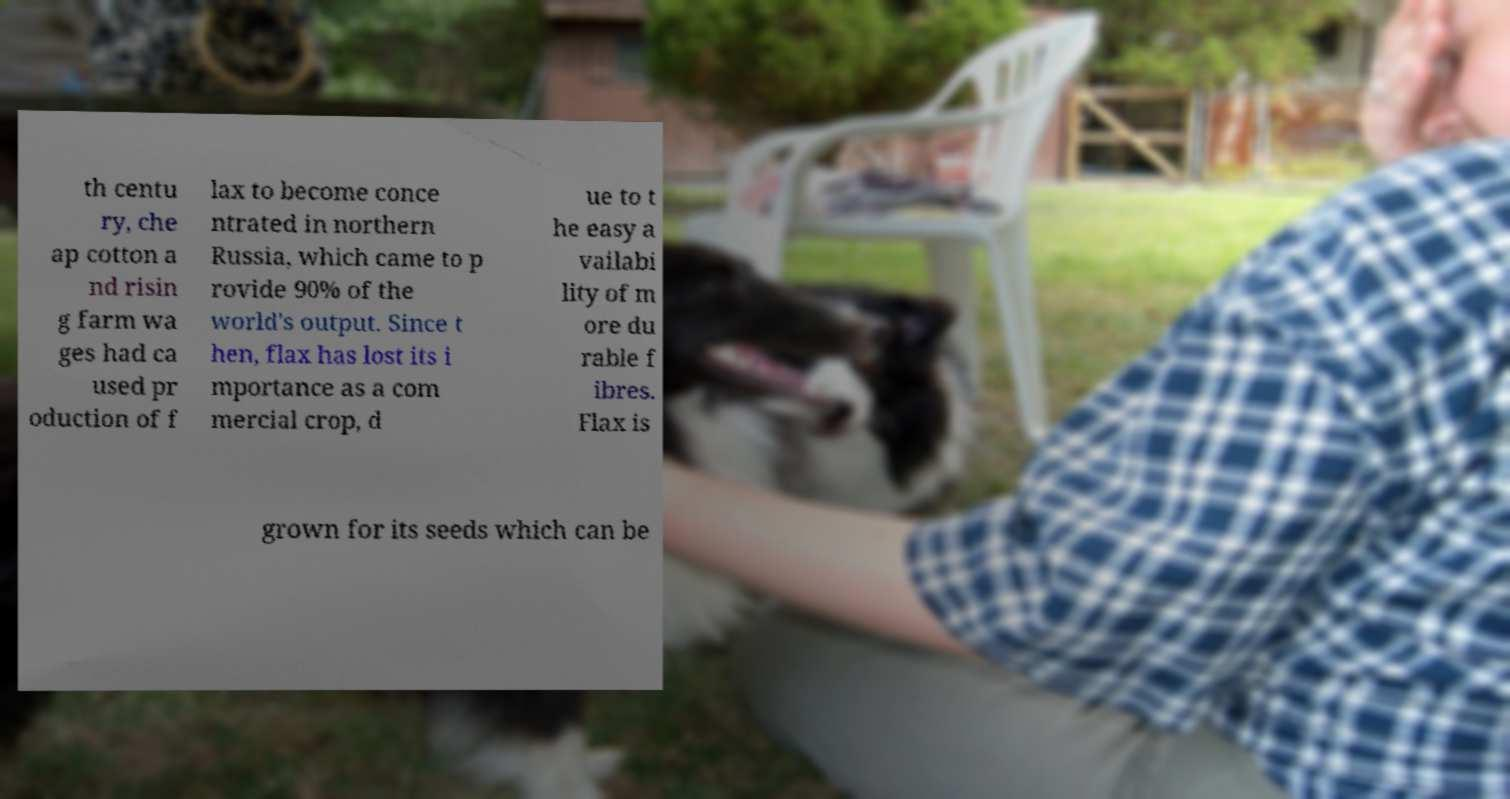Can you read and provide the text displayed in the image?This photo seems to have some interesting text. Can you extract and type it out for me? th centu ry, che ap cotton a nd risin g farm wa ges had ca used pr oduction of f lax to become conce ntrated in northern Russia, which came to p rovide 90% of the world's output. Since t hen, flax has lost its i mportance as a com mercial crop, d ue to t he easy a vailabi lity of m ore du rable f ibres. Flax is grown for its seeds which can be 